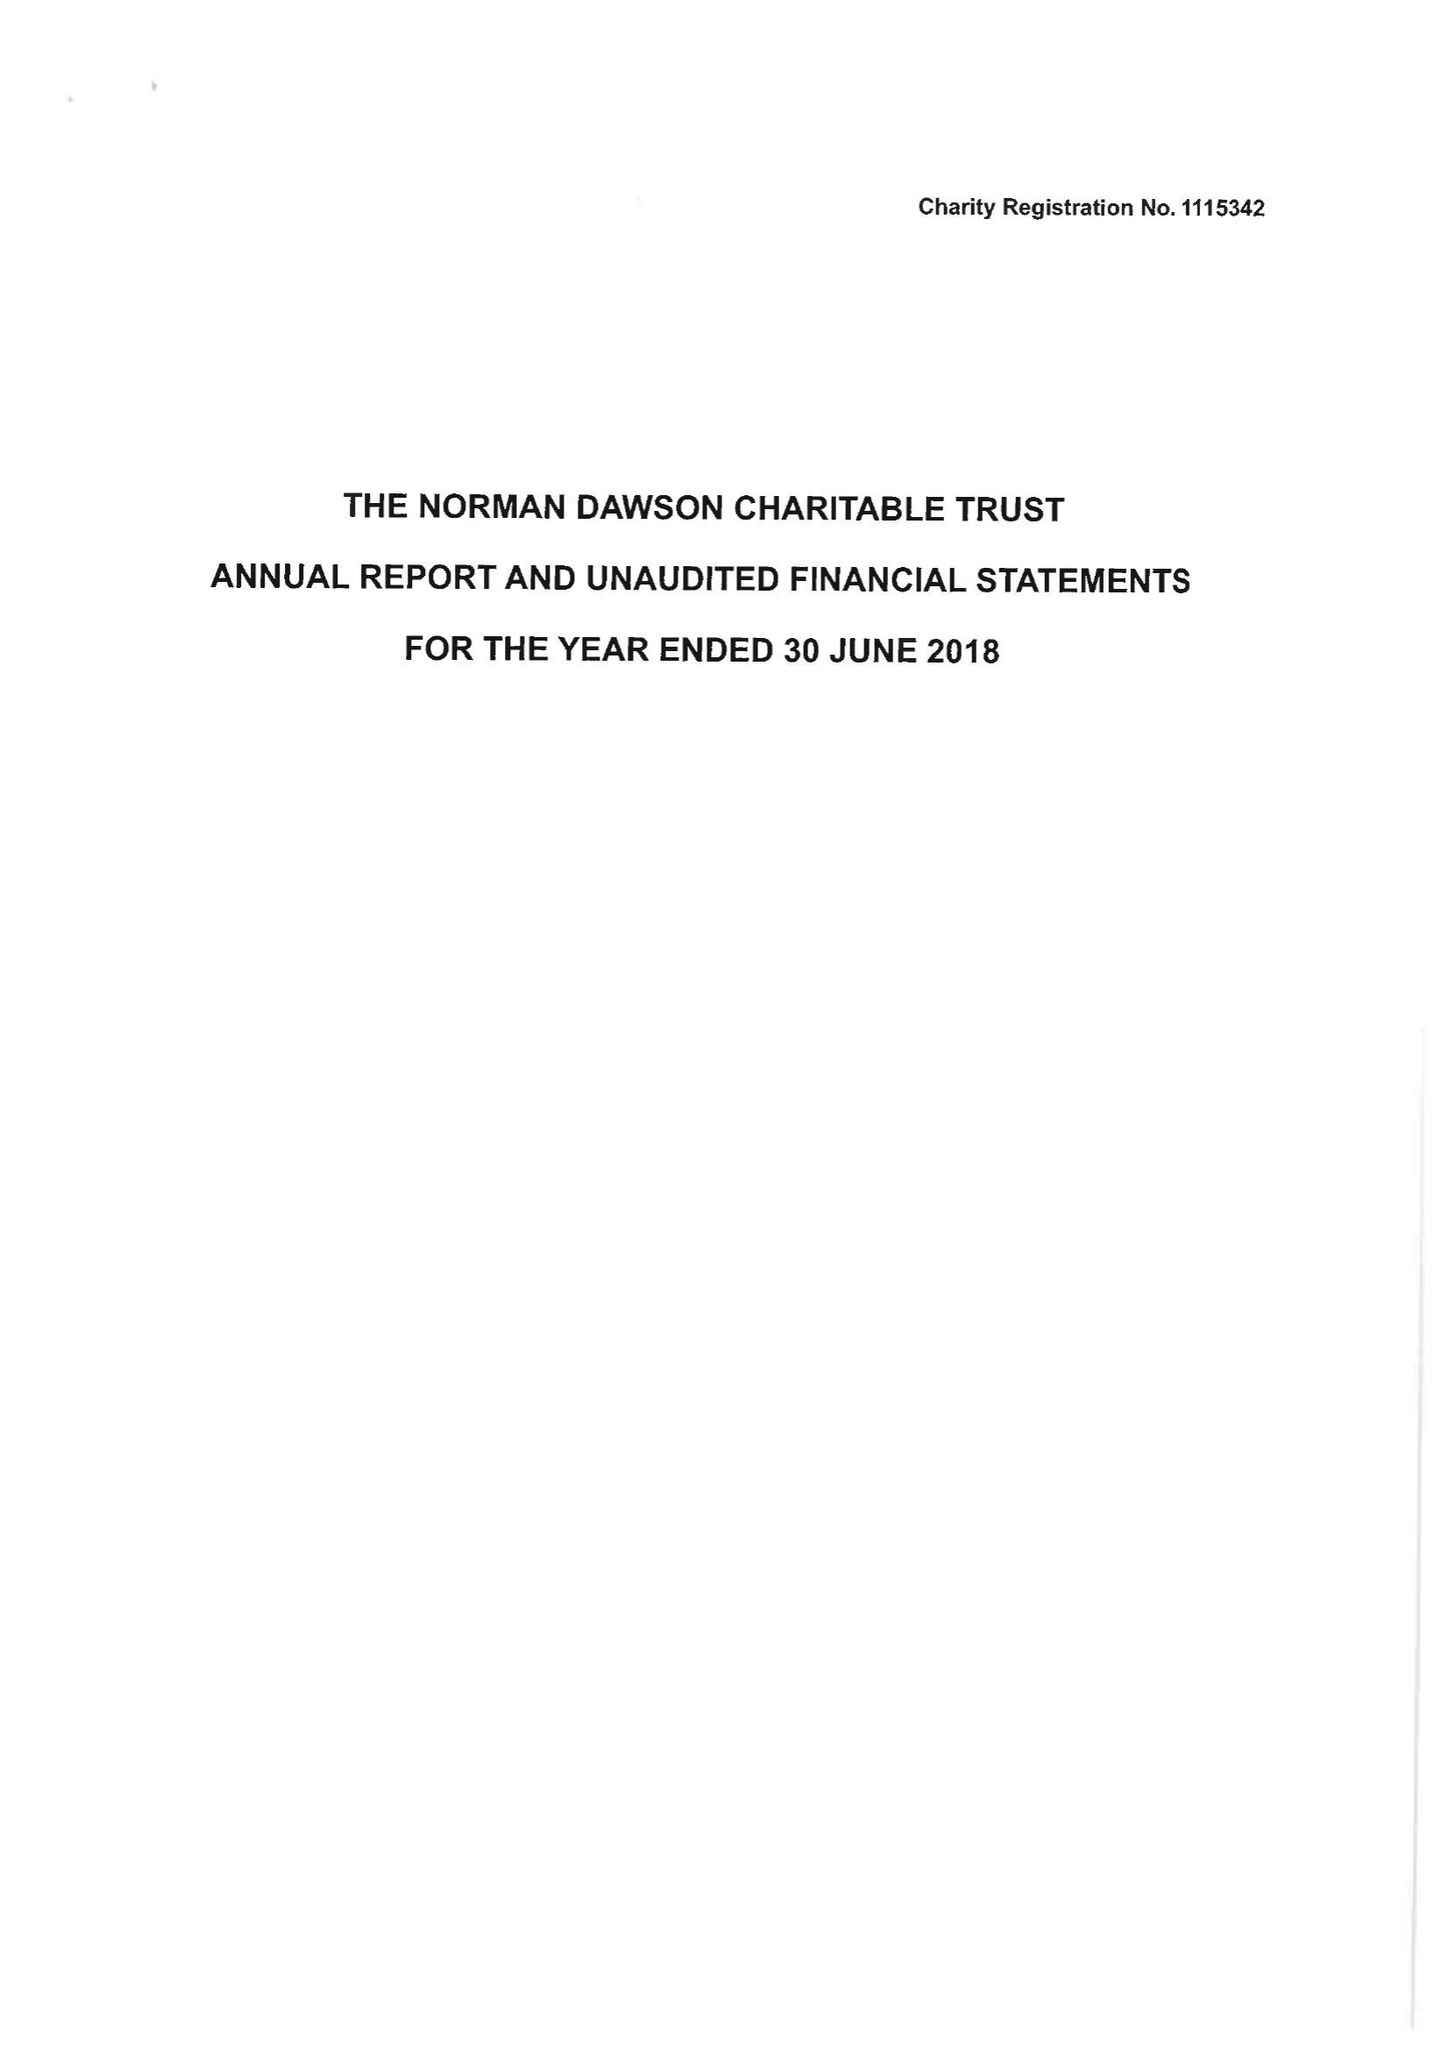What is the value for the address__street_line?
Answer the question using a single word or phrase. BIRMINGHAM ROAD 